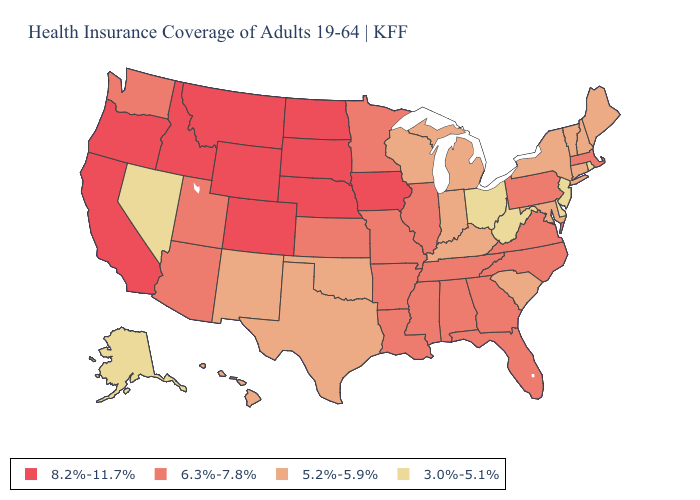What is the highest value in states that border Montana?
Short answer required. 8.2%-11.7%. What is the highest value in the Northeast ?
Keep it brief. 6.3%-7.8%. Name the states that have a value in the range 8.2%-11.7%?
Quick response, please. California, Colorado, Idaho, Iowa, Montana, Nebraska, North Dakota, Oregon, South Dakota, Wyoming. Name the states that have a value in the range 5.2%-5.9%?
Write a very short answer. Connecticut, Hawaii, Indiana, Kentucky, Maine, Maryland, Michigan, New Hampshire, New Mexico, New York, Oklahoma, South Carolina, Texas, Vermont, Wisconsin. Name the states that have a value in the range 8.2%-11.7%?
Be succinct. California, Colorado, Idaho, Iowa, Montana, Nebraska, North Dakota, Oregon, South Dakota, Wyoming. Name the states that have a value in the range 8.2%-11.7%?
Concise answer only. California, Colorado, Idaho, Iowa, Montana, Nebraska, North Dakota, Oregon, South Dakota, Wyoming. What is the lowest value in the MidWest?
Concise answer only. 3.0%-5.1%. Name the states that have a value in the range 6.3%-7.8%?
Write a very short answer. Alabama, Arizona, Arkansas, Florida, Georgia, Illinois, Kansas, Louisiana, Massachusetts, Minnesota, Mississippi, Missouri, North Carolina, Pennsylvania, Tennessee, Utah, Virginia, Washington. What is the value of North Dakota?
Keep it brief. 8.2%-11.7%. Which states have the lowest value in the West?
Short answer required. Alaska, Nevada. What is the highest value in states that border North Dakota?
Keep it brief. 8.2%-11.7%. What is the highest value in the South ?
Answer briefly. 6.3%-7.8%. Among the states that border New Jersey , which have the highest value?
Answer briefly. Pennsylvania. Name the states that have a value in the range 6.3%-7.8%?
Answer briefly. Alabama, Arizona, Arkansas, Florida, Georgia, Illinois, Kansas, Louisiana, Massachusetts, Minnesota, Mississippi, Missouri, North Carolina, Pennsylvania, Tennessee, Utah, Virginia, Washington. Name the states that have a value in the range 6.3%-7.8%?
Keep it brief. Alabama, Arizona, Arkansas, Florida, Georgia, Illinois, Kansas, Louisiana, Massachusetts, Minnesota, Mississippi, Missouri, North Carolina, Pennsylvania, Tennessee, Utah, Virginia, Washington. 